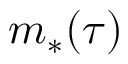Convert formula to latex. <formula><loc_0><loc_0><loc_500><loc_500>m _ { * } ( \tau )</formula> 